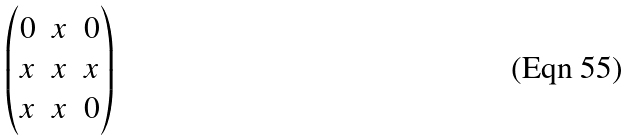<formula> <loc_0><loc_0><loc_500><loc_500>\begin{pmatrix} 0 & x & 0 \\ x & x & x \\ x & x & 0 \\ \end{pmatrix}</formula> 